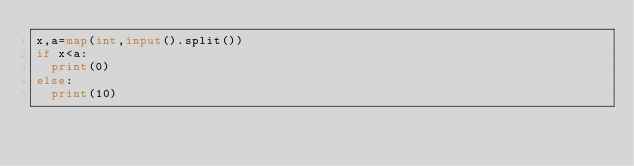Convert code to text. <code><loc_0><loc_0><loc_500><loc_500><_Python_>x,a=map(int,input().split())
if x<a:
	print(0)
else:
	print(10)</code> 